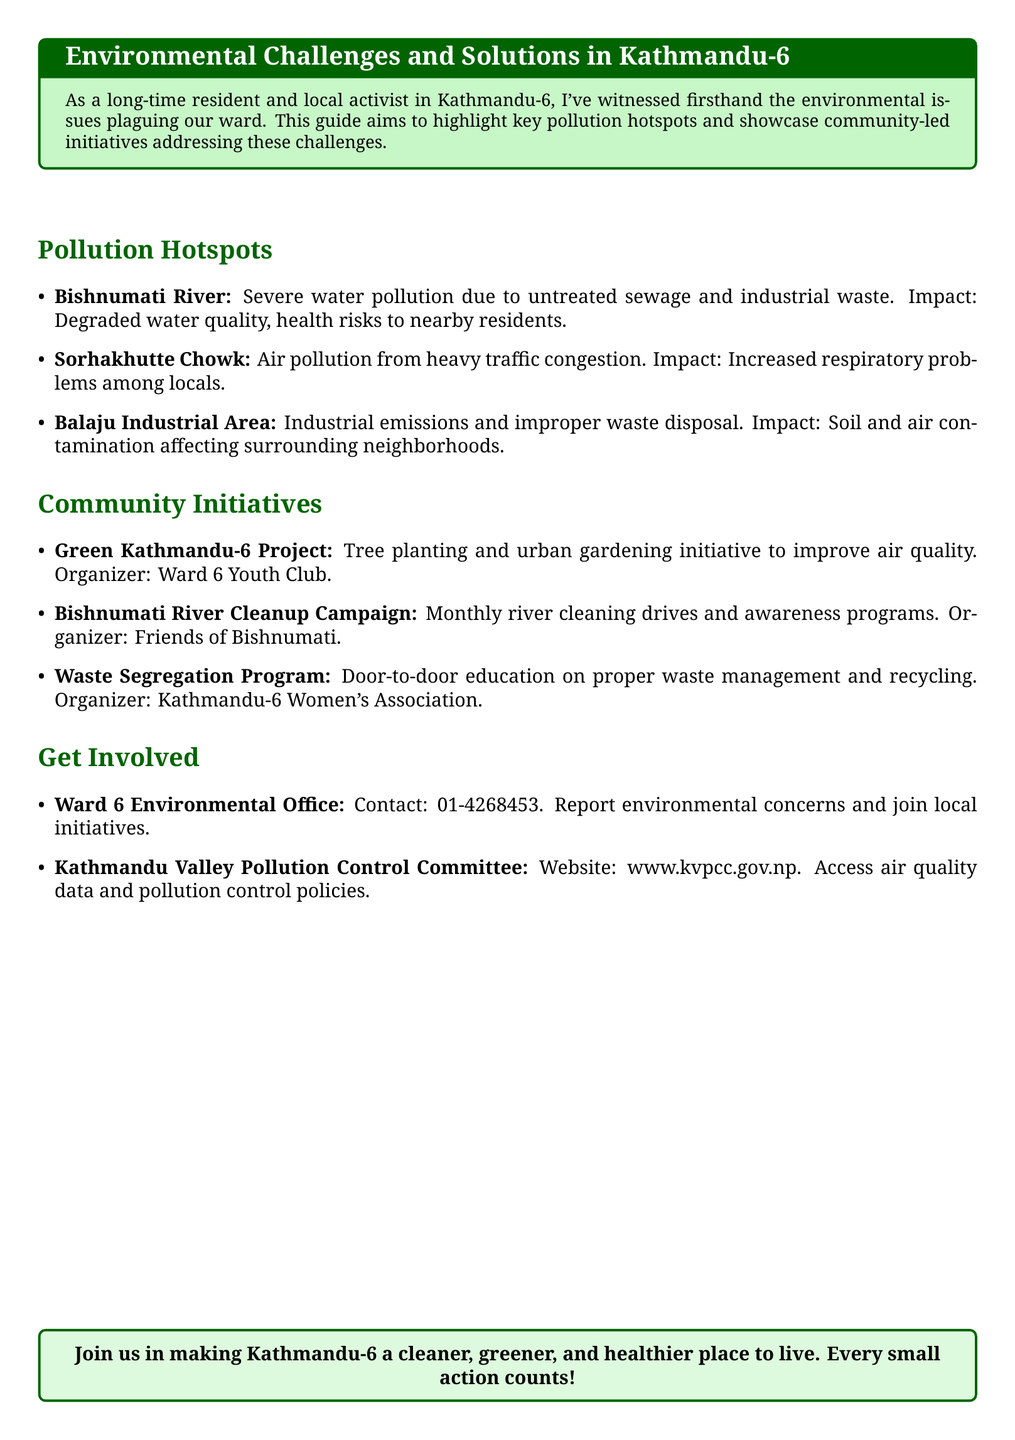What is the most severe pollution source in Bishnumati River? The document mentions that Bishnumati River suffers from severe water pollution due to untreated sewage and industrial waste.
Answer: untreated sewage and industrial waste What organization is behind the Green Kathmandu-6 Project? The Green Kathmandu-6 Project is organized by the Ward 6 Youth Club.
Answer: Ward 6 Youth Club How often does the Bishnumati River Cleanup Campaign take place? The document states that the campaign involves monthly river cleaning drives.
Answer: monthly What is the primary impact of pollution at Sorhakhutte Chowk? The document indicates that air pollution from heavy traffic congestion leads to increased respiratory problems among locals.
Answer: increased respiratory problems What initiative focuses on waste management education? The Waste Segregation Program is the initiative that offers door-to-door education on proper waste management and recycling.
Answer: Waste Segregation Program Which committee provides access to air quality data? The Kathmandu Valley Pollution Control Committee provides access to air quality data and pollution control policies.
Answer: Kathmandu Valley Pollution Control Committee What type of local community project is the Green Kathmandu-6 Project? The project is primarily focused on tree planting and urban gardening initiatives.
Answer: tree planting and urban gardening What is the contact number for the Ward 6 Environmental Office? The document provides a specific contact number for reporting environmental concerns and joining initiatives.
Answer: 01-4268453 